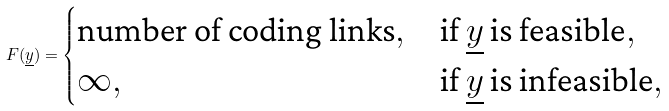Convert formula to latex. <formula><loc_0><loc_0><loc_500><loc_500>F ( \underline { y } ) = \begin{cases} \text {number of coding links} , & \text {if } \underline { y } \text { is feasible} , \\ \infty , & \text {if } \underline { y } \text { is infeasible} , \end{cases}</formula> 